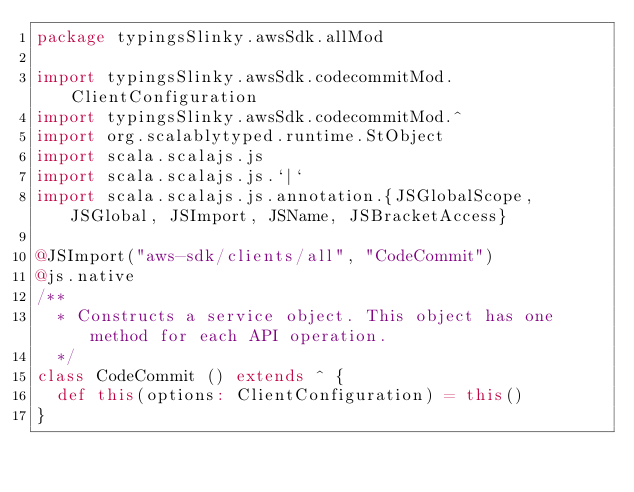<code> <loc_0><loc_0><loc_500><loc_500><_Scala_>package typingsSlinky.awsSdk.allMod

import typingsSlinky.awsSdk.codecommitMod.ClientConfiguration
import typingsSlinky.awsSdk.codecommitMod.^
import org.scalablytyped.runtime.StObject
import scala.scalajs.js
import scala.scalajs.js.`|`
import scala.scalajs.js.annotation.{JSGlobalScope, JSGlobal, JSImport, JSName, JSBracketAccess}

@JSImport("aws-sdk/clients/all", "CodeCommit")
@js.native
/**
  * Constructs a service object. This object has one method for each API operation.
  */
class CodeCommit () extends ^ {
  def this(options: ClientConfiguration) = this()
}
</code> 